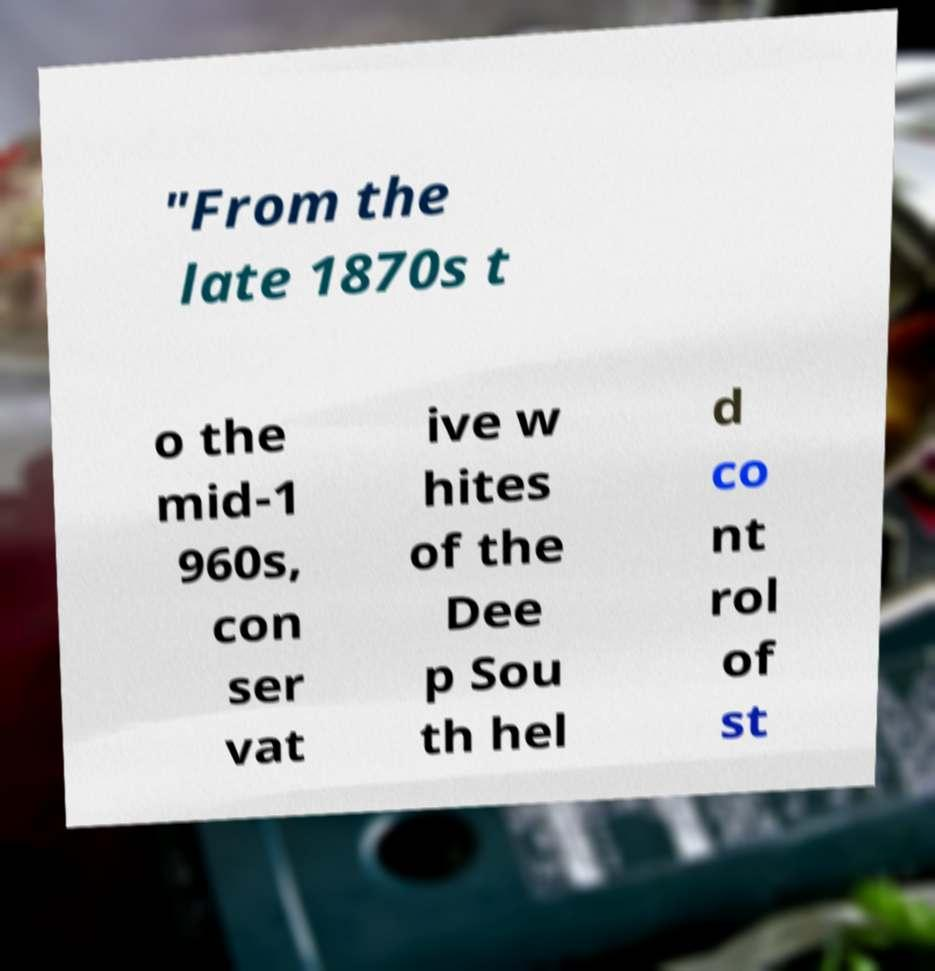Please identify and transcribe the text found in this image. "From the late 1870s t o the mid-1 960s, con ser vat ive w hites of the Dee p Sou th hel d co nt rol of st 